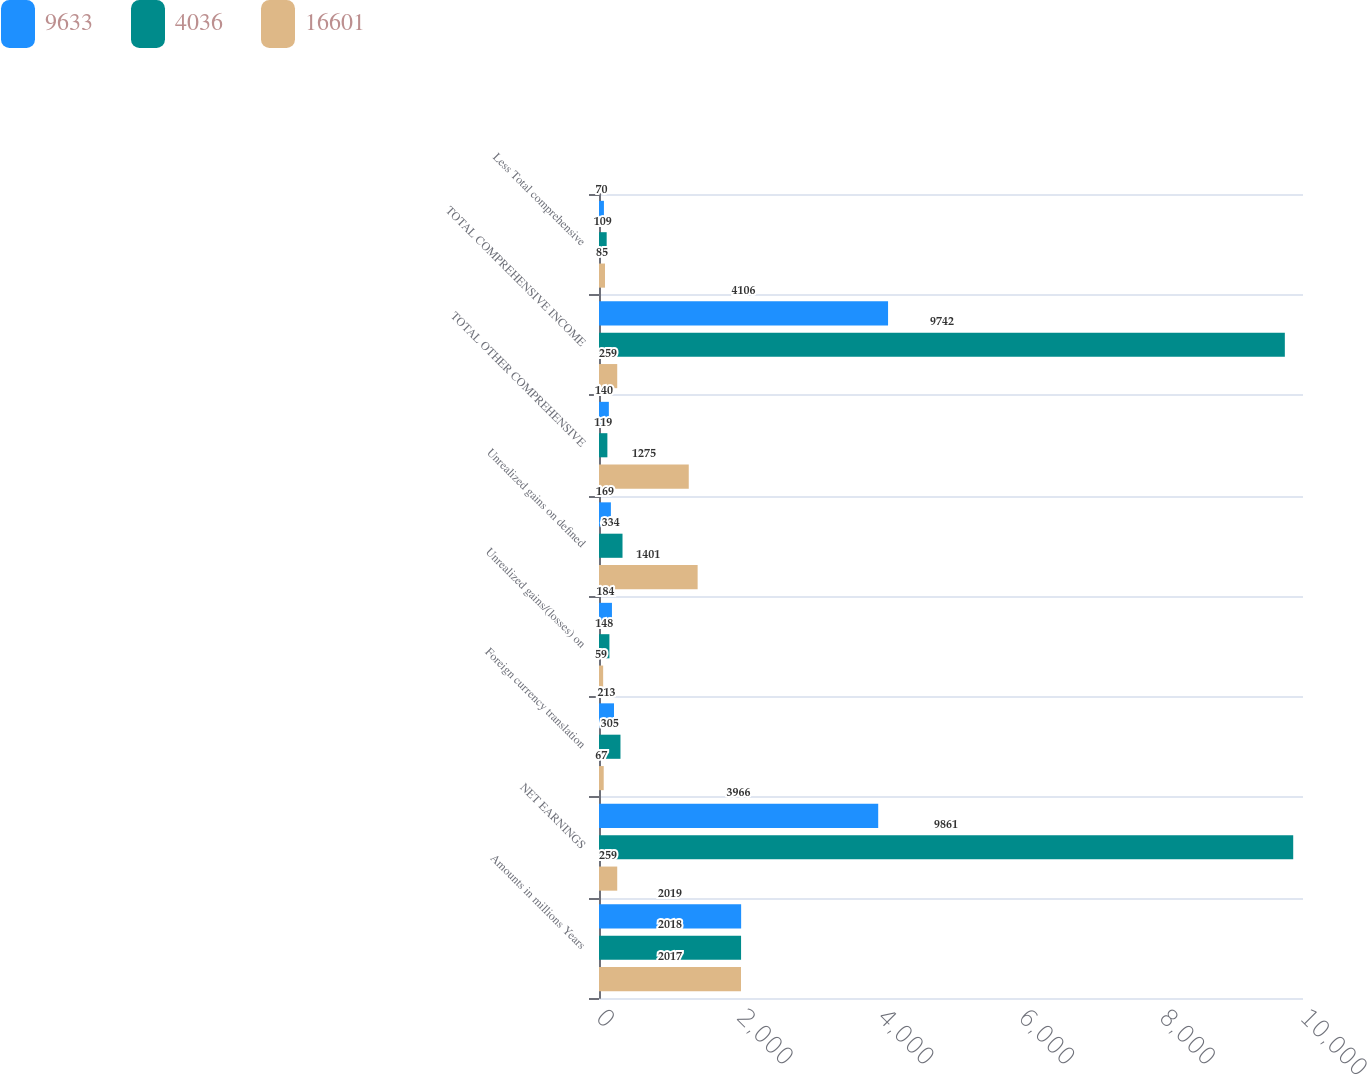Convert chart to OTSL. <chart><loc_0><loc_0><loc_500><loc_500><stacked_bar_chart><ecel><fcel>Amounts in millions Years<fcel>NET EARNINGS<fcel>Foreign currency translation<fcel>Unrealized gains/(losses) on<fcel>Unrealized gains on defined<fcel>TOTAL OTHER COMPREHENSIVE<fcel>TOTAL COMPREHENSIVE INCOME<fcel>Less Total comprehensive<nl><fcel>9633<fcel>2019<fcel>3966<fcel>213<fcel>184<fcel>169<fcel>140<fcel>4106<fcel>70<nl><fcel>4036<fcel>2018<fcel>9861<fcel>305<fcel>148<fcel>334<fcel>119<fcel>9742<fcel>109<nl><fcel>16601<fcel>2017<fcel>259<fcel>67<fcel>59<fcel>1401<fcel>1275<fcel>259<fcel>85<nl></chart> 